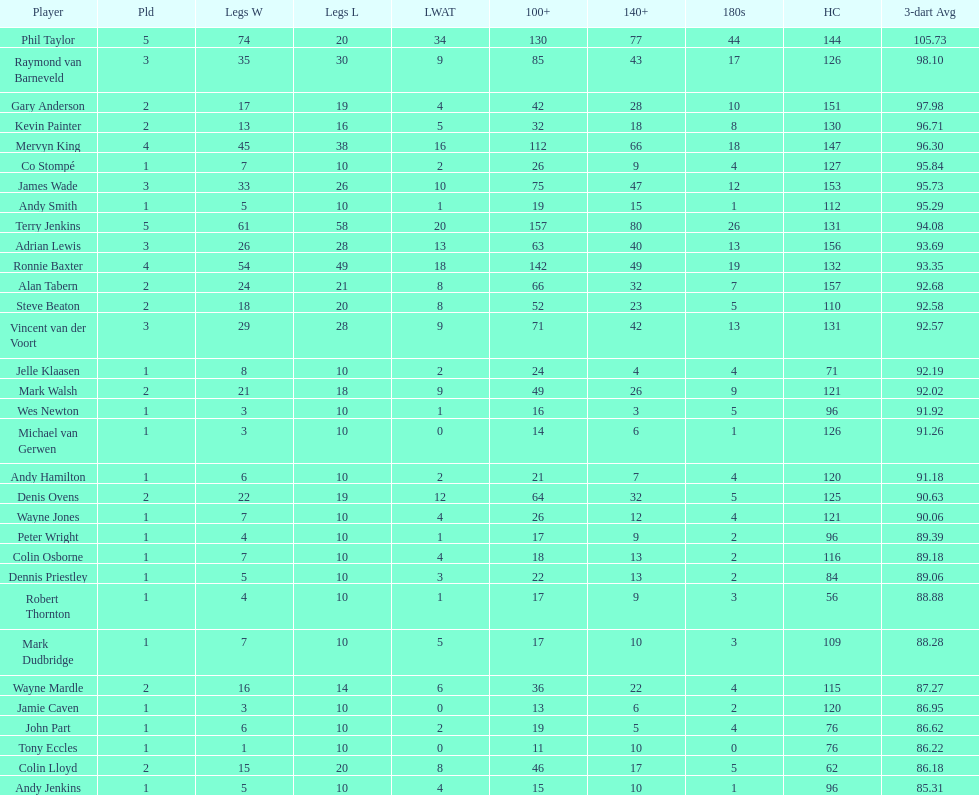What is the name of the next player after mark walsh? Wes Newton. 